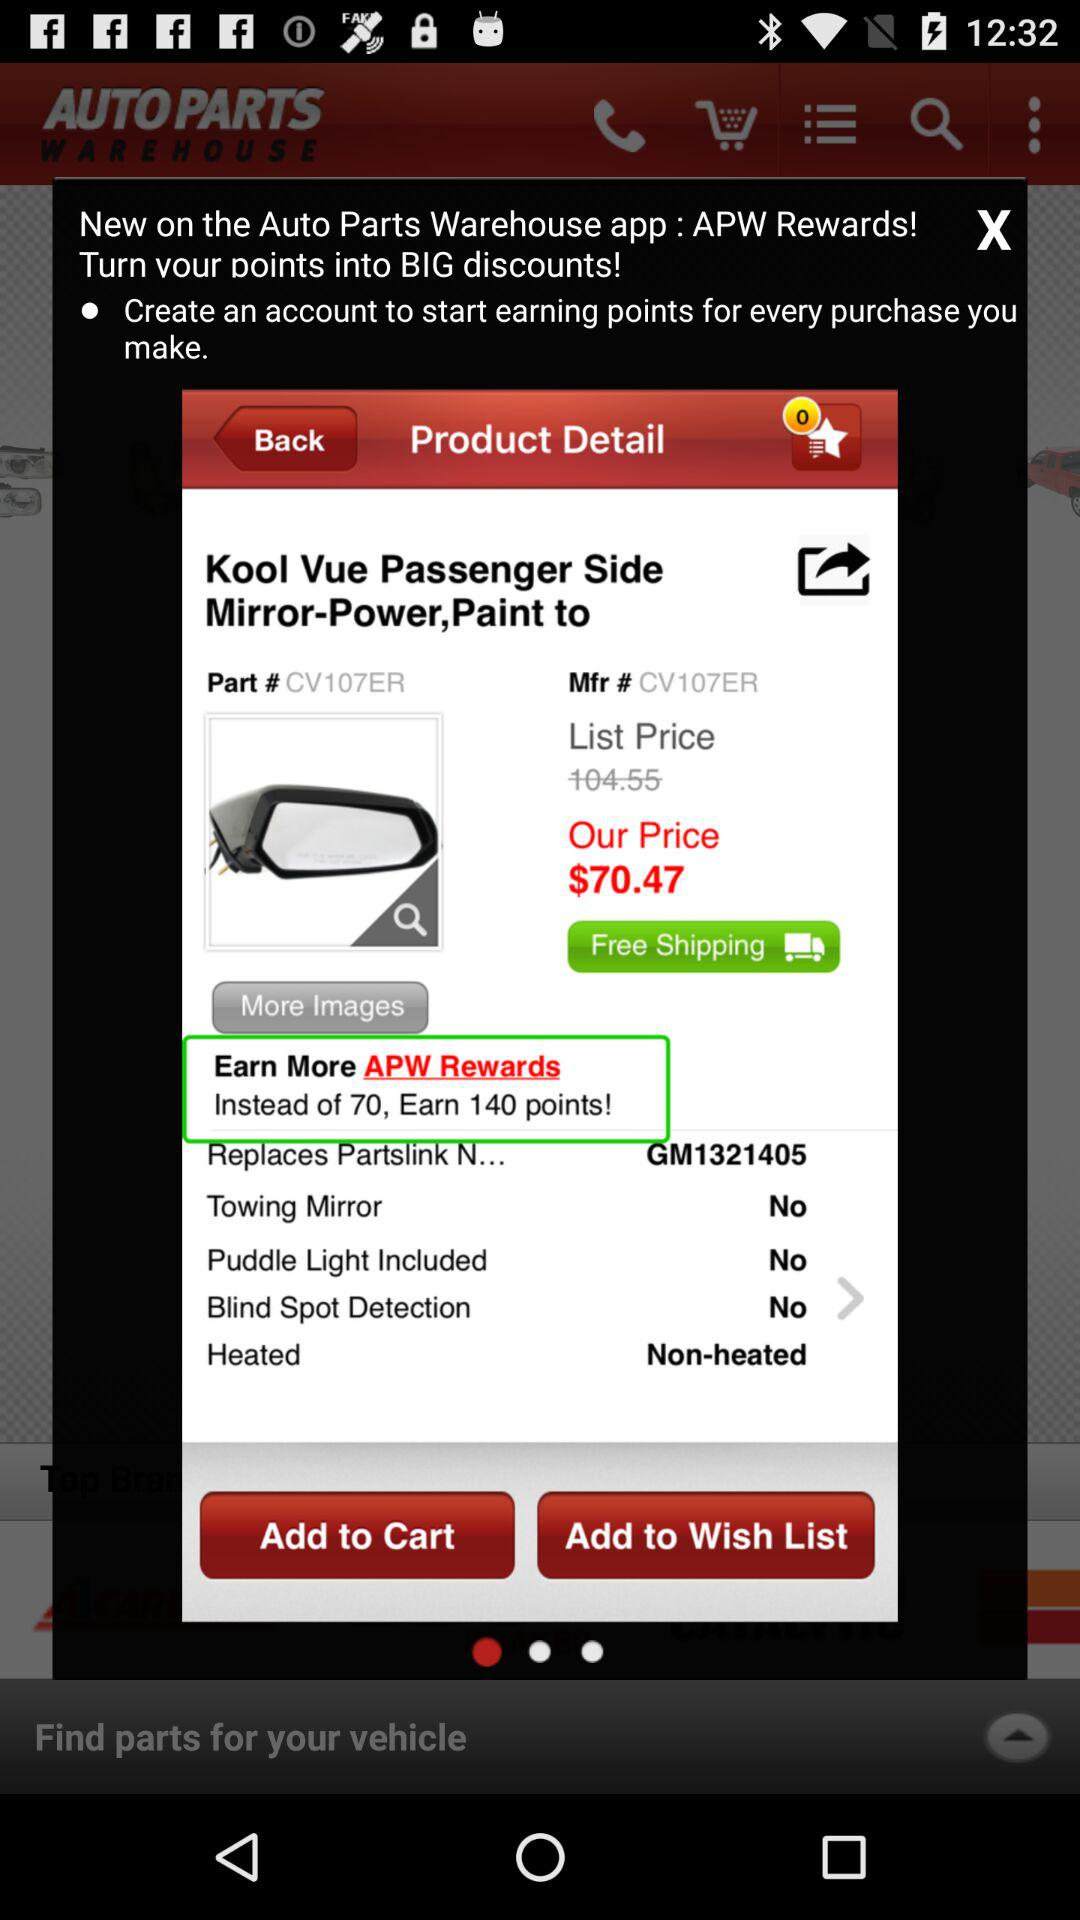How many items are in the wish list?
When the provided information is insufficient, respond with <no answer>. <no answer> 